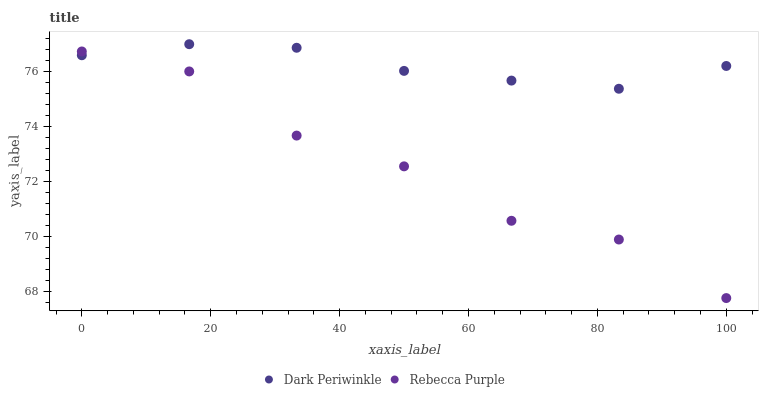Does Rebecca Purple have the minimum area under the curve?
Answer yes or no. Yes. Does Dark Periwinkle have the maximum area under the curve?
Answer yes or no. Yes. Does Rebecca Purple have the maximum area under the curve?
Answer yes or no. No. Is Dark Periwinkle the smoothest?
Answer yes or no. Yes. Is Rebecca Purple the roughest?
Answer yes or no. Yes. Is Rebecca Purple the smoothest?
Answer yes or no. No. Does Rebecca Purple have the lowest value?
Answer yes or no. Yes. Does Dark Periwinkle have the highest value?
Answer yes or no. Yes. Does Rebecca Purple have the highest value?
Answer yes or no. No. Does Rebecca Purple intersect Dark Periwinkle?
Answer yes or no. Yes. Is Rebecca Purple less than Dark Periwinkle?
Answer yes or no. No. Is Rebecca Purple greater than Dark Periwinkle?
Answer yes or no. No. 